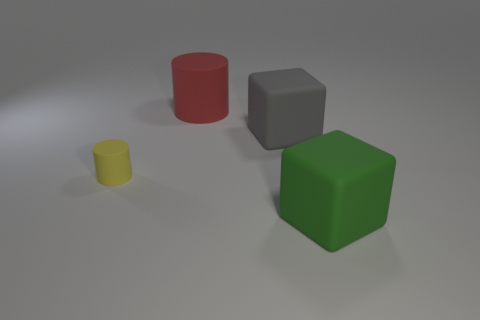What material is the green block? Based on the image, the green block could be made of rubber due to its matte finish and the way it interacts with the light, giving it a soft appearance. However, since images do not provide tactile feedback or material specifics, it's also possible it could be painted wood or plastic designed to resemble rubber. 